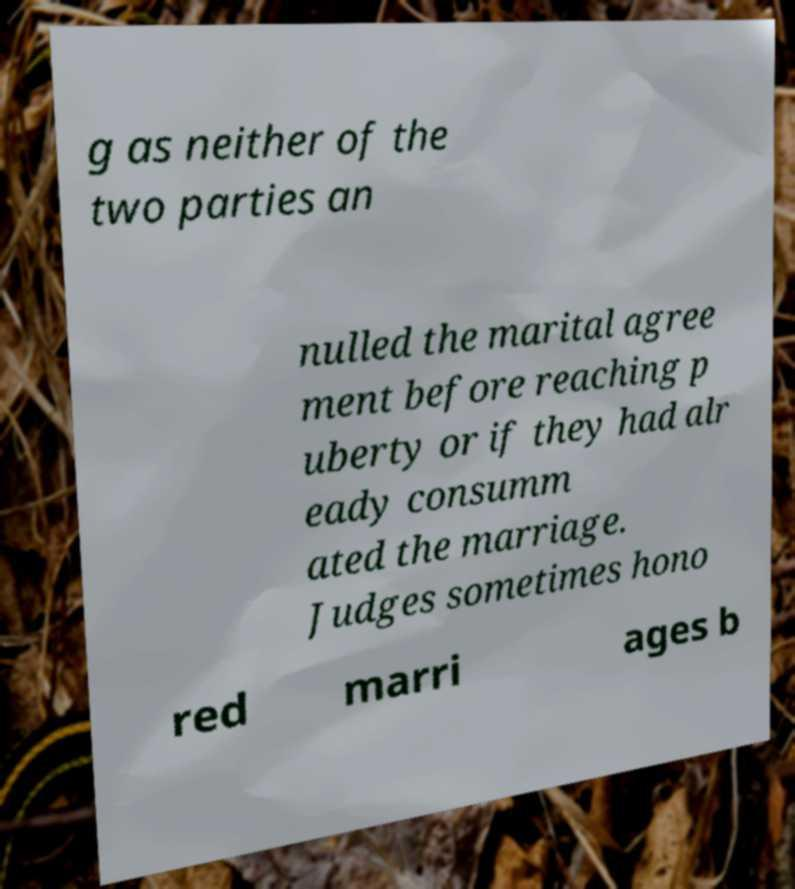Please identify and transcribe the text found in this image. g as neither of the two parties an nulled the marital agree ment before reaching p uberty or if they had alr eady consumm ated the marriage. Judges sometimes hono red marri ages b 